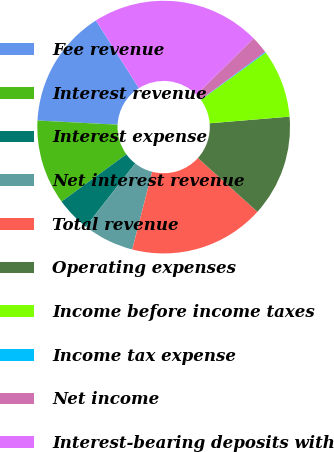Convert chart to OTSL. <chart><loc_0><loc_0><loc_500><loc_500><pie_chart><fcel>Fee revenue<fcel>Interest revenue<fcel>Interest expense<fcel>Net interest revenue<fcel>Total revenue<fcel>Operating expenses<fcel>Income before income taxes<fcel>Income tax expense<fcel>Net income<fcel>Interest-bearing deposits with<nl><fcel>15.16%<fcel>10.86%<fcel>4.41%<fcel>6.56%<fcel>17.31%<fcel>13.01%<fcel>8.71%<fcel>0.11%<fcel>2.26%<fcel>21.61%<nl></chart> 